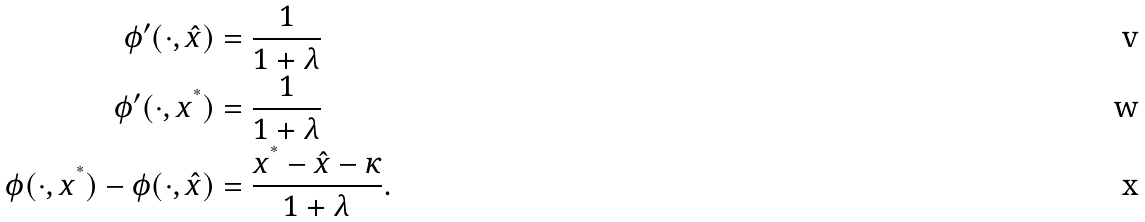Convert formula to latex. <formula><loc_0><loc_0><loc_500><loc_500>\phi ^ { \prime } ( \cdot , \hat { x } ) & = \frac { 1 } { 1 + \lambda } \\ \phi ^ { \prime } ( \cdot , x ^ { ^ { * } } ) & = \frac { 1 } { 1 + \lambda } \\ \phi ( \cdot , x ^ { ^ { * } } ) - \phi ( \cdot , \hat { x } ) & = \frac { x ^ { ^ { * } } - \hat { x } - \kappa } { 1 + \lambda } .</formula> 